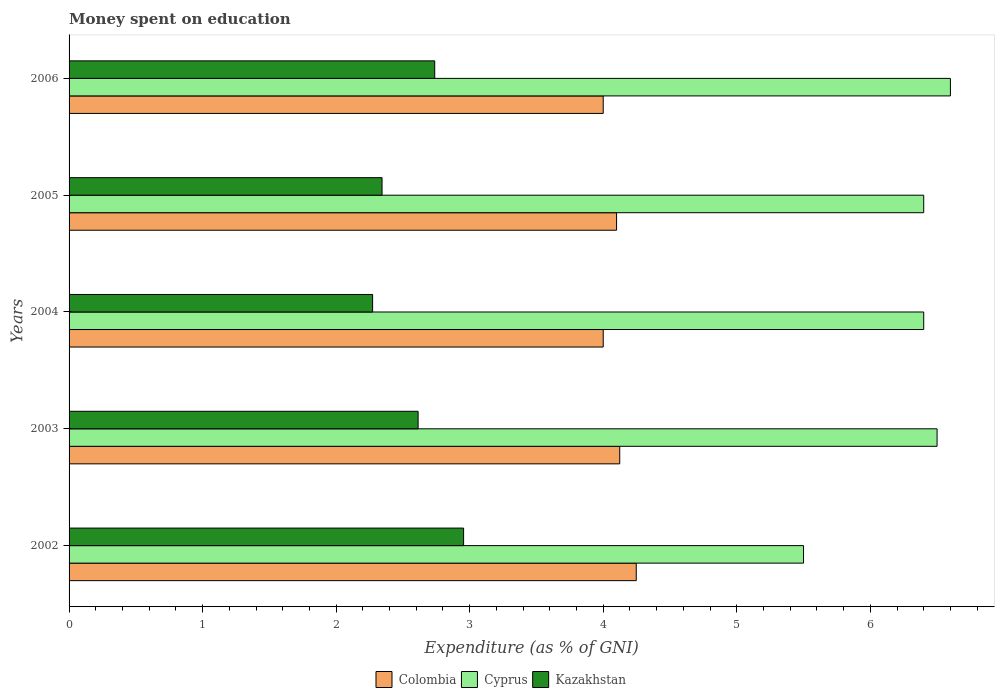How many different coloured bars are there?
Give a very brief answer. 3. How many groups of bars are there?
Make the answer very short. 5. Are the number of bars on each tick of the Y-axis equal?
Make the answer very short. Yes. How many bars are there on the 2nd tick from the top?
Offer a very short reply. 3. How many bars are there on the 1st tick from the bottom?
Ensure brevity in your answer.  3. What is the label of the 3rd group of bars from the top?
Your answer should be very brief. 2004. What is the amount of money spent on education in Colombia in 2002?
Ensure brevity in your answer.  4.25. Across all years, what is the maximum amount of money spent on education in Cyprus?
Provide a succinct answer. 6.6. Across all years, what is the minimum amount of money spent on education in Cyprus?
Give a very brief answer. 5.5. In which year was the amount of money spent on education in Kazakhstan maximum?
Your answer should be compact. 2002. What is the total amount of money spent on education in Cyprus in the graph?
Your answer should be compact. 31.4. What is the difference between the amount of money spent on education in Kazakhstan in 2002 and that in 2006?
Offer a terse response. 0.22. What is the difference between the amount of money spent on education in Cyprus in 2004 and the amount of money spent on education in Kazakhstan in 2003?
Keep it short and to the point. 3.79. What is the average amount of money spent on education in Colombia per year?
Your answer should be very brief. 4.09. In the year 2004, what is the difference between the amount of money spent on education in Kazakhstan and amount of money spent on education in Cyprus?
Give a very brief answer. -4.13. What is the ratio of the amount of money spent on education in Cyprus in 2002 to that in 2004?
Ensure brevity in your answer.  0.86. What is the difference between the highest and the second highest amount of money spent on education in Colombia?
Give a very brief answer. 0.12. What is the difference between the highest and the lowest amount of money spent on education in Cyprus?
Provide a short and direct response. 1.1. What does the 3rd bar from the top in 2005 represents?
Ensure brevity in your answer.  Colombia. What does the 3rd bar from the bottom in 2003 represents?
Provide a short and direct response. Kazakhstan. How many years are there in the graph?
Provide a succinct answer. 5. What is the difference between two consecutive major ticks on the X-axis?
Ensure brevity in your answer.  1. Are the values on the major ticks of X-axis written in scientific E-notation?
Ensure brevity in your answer.  No. Does the graph contain grids?
Your answer should be very brief. No. What is the title of the graph?
Keep it short and to the point. Money spent on education. What is the label or title of the X-axis?
Provide a succinct answer. Expenditure (as % of GNI). What is the label or title of the Y-axis?
Offer a very short reply. Years. What is the Expenditure (as % of GNI) of Colombia in 2002?
Make the answer very short. 4.25. What is the Expenditure (as % of GNI) in Kazakhstan in 2002?
Make the answer very short. 2.95. What is the Expenditure (as % of GNI) in Colombia in 2003?
Provide a succinct answer. 4.12. What is the Expenditure (as % of GNI) of Cyprus in 2003?
Make the answer very short. 6.5. What is the Expenditure (as % of GNI) in Kazakhstan in 2003?
Provide a succinct answer. 2.61. What is the Expenditure (as % of GNI) of Kazakhstan in 2004?
Offer a terse response. 2.27. What is the Expenditure (as % of GNI) in Colombia in 2005?
Give a very brief answer. 4.1. What is the Expenditure (as % of GNI) in Cyprus in 2005?
Your answer should be compact. 6.4. What is the Expenditure (as % of GNI) in Kazakhstan in 2005?
Your answer should be compact. 2.34. What is the Expenditure (as % of GNI) in Cyprus in 2006?
Your answer should be compact. 6.6. What is the Expenditure (as % of GNI) of Kazakhstan in 2006?
Your answer should be very brief. 2.74. Across all years, what is the maximum Expenditure (as % of GNI) in Colombia?
Your response must be concise. 4.25. Across all years, what is the maximum Expenditure (as % of GNI) in Cyprus?
Your response must be concise. 6.6. Across all years, what is the maximum Expenditure (as % of GNI) in Kazakhstan?
Your response must be concise. 2.95. Across all years, what is the minimum Expenditure (as % of GNI) in Cyprus?
Provide a succinct answer. 5.5. Across all years, what is the minimum Expenditure (as % of GNI) in Kazakhstan?
Make the answer very short. 2.27. What is the total Expenditure (as % of GNI) in Colombia in the graph?
Provide a succinct answer. 20.47. What is the total Expenditure (as % of GNI) of Cyprus in the graph?
Offer a terse response. 31.4. What is the total Expenditure (as % of GNI) of Kazakhstan in the graph?
Ensure brevity in your answer.  12.92. What is the difference between the Expenditure (as % of GNI) of Colombia in 2002 and that in 2003?
Ensure brevity in your answer.  0.12. What is the difference between the Expenditure (as % of GNI) in Kazakhstan in 2002 and that in 2003?
Offer a very short reply. 0.34. What is the difference between the Expenditure (as % of GNI) in Colombia in 2002 and that in 2004?
Offer a terse response. 0.25. What is the difference between the Expenditure (as % of GNI) of Kazakhstan in 2002 and that in 2004?
Provide a succinct answer. 0.68. What is the difference between the Expenditure (as % of GNI) of Colombia in 2002 and that in 2005?
Offer a very short reply. 0.15. What is the difference between the Expenditure (as % of GNI) of Kazakhstan in 2002 and that in 2005?
Give a very brief answer. 0.61. What is the difference between the Expenditure (as % of GNI) in Colombia in 2002 and that in 2006?
Provide a short and direct response. 0.25. What is the difference between the Expenditure (as % of GNI) in Cyprus in 2002 and that in 2006?
Offer a very short reply. -1.1. What is the difference between the Expenditure (as % of GNI) in Kazakhstan in 2002 and that in 2006?
Ensure brevity in your answer.  0.22. What is the difference between the Expenditure (as % of GNI) in Colombia in 2003 and that in 2004?
Your answer should be compact. 0.12. What is the difference between the Expenditure (as % of GNI) of Cyprus in 2003 and that in 2004?
Provide a succinct answer. 0.1. What is the difference between the Expenditure (as % of GNI) in Kazakhstan in 2003 and that in 2004?
Offer a terse response. 0.34. What is the difference between the Expenditure (as % of GNI) in Colombia in 2003 and that in 2005?
Keep it short and to the point. 0.02. What is the difference between the Expenditure (as % of GNI) of Kazakhstan in 2003 and that in 2005?
Your response must be concise. 0.27. What is the difference between the Expenditure (as % of GNI) of Colombia in 2003 and that in 2006?
Provide a short and direct response. 0.12. What is the difference between the Expenditure (as % of GNI) of Kazakhstan in 2003 and that in 2006?
Offer a very short reply. -0.12. What is the difference between the Expenditure (as % of GNI) of Cyprus in 2004 and that in 2005?
Give a very brief answer. 0. What is the difference between the Expenditure (as % of GNI) in Kazakhstan in 2004 and that in 2005?
Offer a very short reply. -0.07. What is the difference between the Expenditure (as % of GNI) of Colombia in 2004 and that in 2006?
Provide a succinct answer. 0. What is the difference between the Expenditure (as % of GNI) of Cyprus in 2004 and that in 2006?
Make the answer very short. -0.2. What is the difference between the Expenditure (as % of GNI) in Kazakhstan in 2004 and that in 2006?
Provide a succinct answer. -0.47. What is the difference between the Expenditure (as % of GNI) of Colombia in 2005 and that in 2006?
Keep it short and to the point. 0.1. What is the difference between the Expenditure (as % of GNI) in Kazakhstan in 2005 and that in 2006?
Keep it short and to the point. -0.39. What is the difference between the Expenditure (as % of GNI) in Colombia in 2002 and the Expenditure (as % of GNI) in Cyprus in 2003?
Make the answer very short. -2.25. What is the difference between the Expenditure (as % of GNI) in Colombia in 2002 and the Expenditure (as % of GNI) in Kazakhstan in 2003?
Keep it short and to the point. 1.63. What is the difference between the Expenditure (as % of GNI) in Cyprus in 2002 and the Expenditure (as % of GNI) in Kazakhstan in 2003?
Keep it short and to the point. 2.89. What is the difference between the Expenditure (as % of GNI) in Colombia in 2002 and the Expenditure (as % of GNI) in Cyprus in 2004?
Your response must be concise. -2.15. What is the difference between the Expenditure (as % of GNI) in Colombia in 2002 and the Expenditure (as % of GNI) in Kazakhstan in 2004?
Offer a terse response. 1.97. What is the difference between the Expenditure (as % of GNI) in Cyprus in 2002 and the Expenditure (as % of GNI) in Kazakhstan in 2004?
Give a very brief answer. 3.23. What is the difference between the Expenditure (as % of GNI) in Colombia in 2002 and the Expenditure (as % of GNI) in Cyprus in 2005?
Your answer should be very brief. -2.15. What is the difference between the Expenditure (as % of GNI) of Colombia in 2002 and the Expenditure (as % of GNI) of Kazakhstan in 2005?
Keep it short and to the point. 1.9. What is the difference between the Expenditure (as % of GNI) of Cyprus in 2002 and the Expenditure (as % of GNI) of Kazakhstan in 2005?
Your response must be concise. 3.16. What is the difference between the Expenditure (as % of GNI) in Colombia in 2002 and the Expenditure (as % of GNI) in Cyprus in 2006?
Ensure brevity in your answer.  -2.35. What is the difference between the Expenditure (as % of GNI) of Colombia in 2002 and the Expenditure (as % of GNI) of Kazakhstan in 2006?
Keep it short and to the point. 1.51. What is the difference between the Expenditure (as % of GNI) of Cyprus in 2002 and the Expenditure (as % of GNI) of Kazakhstan in 2006?
Make the answer very short. 2.76. What is the difference between the Expenditure (as % of GNI) of Colombia in 2003 and the Expenditure (as % of GNI) of Cyprus in 2004?
Provide a short and direct response. -2.28. What is the difference between the Expenditure (as % of GNI) of Colombia in 2003 and the Expenditure (as % of GNI) of Kazakhstan in 2004?
Keep it short and to the point. 1.85. What is the difference between the Expenditure (as % of GNI) of Cyprus in 2003 and the Expenditure (as % of GNI) of Kazakhstan in 2004?
Your answer should be very brief. 4.23. What is the difference between the Expenditure (as % of GNI) in Colombia in 2003 and the Expenditure (as % of GNI) in Cyprus in 2005?
Give a very brief answer. -2.28. What is the difference between the Expenditure (as % of GNI) of Colombia in 2003 and the Expenditure (as % of GNI) of Kazakhstan in 2005?
Provide a succinct answer. 1.78. What is the difference between the Expenditure (as % of GNI) of Cyprus in 2003 and the Expenditure (as % of GNI) of Kazakhstan in 2005?
Provide a short and direct response. 4.16. What is the difference between the Expenditure (as % of GNI) of Colombia in 2003 and the Expenditure (as % of GNI) of Cyprus in 2006?
Offer a terse response. -2.48. What is the difference between the Expenditure (as % of GNI) of Colombia in 2003 and the Expenditure (as % of GNI) of Kazakhstan in 2006?
Your response must be concise. 1.39. What is the difference between the Expenditure (as % of GNI) of Cyprus in 2003 and the Expenditure (as % of GNI) of Kazakhstan in 2006?
Ensure brevity in your answer.  3.76. What is the difference between the Expenditure (as % of GNI) in Colombia in 2004 and the Expenditure (as % of GNI) in Cyprus in 2005?
Ensure brevity in your answer.  -2.4. What is the difference between the Expenditure (as % of GNI) of Colombia in 2004 and the Expenditure (as % of GNI) of Kazakhstan in 2005?
Offer a very short reply. 1.66. What is the difference between the Expenditure (as % of GNI) of Cyprus in 2004 and the Expenditure (as % of GNI) of Kazakhstan in 2005?
Offer a very short reply. 4.06. What is the difference between the Expenditure (as % of GNI) of Colombia in 2004 and the Expenditure (as % of GNI) of Kazakhstan in 2006?
Your answer should be compact. 1.26. What is the difference between the Expenditure (as % of GNI) of Cyprus in 2004 and the Expenditure (as % of GNI) of Kazakhstan in 2006?
Offer a very short reply. 3.66. What is the difference between the Expenditure (as % of GNI) in Colombia in 2005 and the Expenditure (as % of GNI) in Cyprus in 2006?
Provide a short and direct response. -2.5. What is the difference between the Expenditure (as % of GNI) of Colombia in 2005 and the Expenditure (as % of GNI) of Kazakhstan in 2006?
Your answer should be very brief. 1.36. What is the difference between the Expenditure (as % of GNI) in Cyprus in 2005 and the Expenditure (as % of GNI) in Kazakhstan in 2006?
Keep it short and to the point. 3.66. What is the average Expenditure (as % of GNI) of Colombia per year?
Make the answer very short. 4.09. What is the average Expenditure (as % of GNI) in Cyprus per year?
Provide a succinct answer. 6.28. What is the average Expenditure (as % of GNI) in Kazakhstan per year?
Ensure brevity in your answer.  2.58. In the year 2002, what is the difference between the Expenditure (as % of GNI) of Colombia and Expenditure (as % of GNI) of Cyprus?
Ensure brevity in your answer.  -1.25. In the year 2002, what is the difference between the Expenditure (as % of GNI) in Colombia and Expenditure (as % of GNI) in Kazakhstan?
Keep it short and to the point. 1.29. In the year 2002, what is the difference between the Expenditure (as % of GNI) in Cyprus and Expenditure (as % of GNI) in Kazakhstan?
Your response must be concise. 2.55. In the year 2003, what is the difference between the Expenditure (as % of GNI) of Colombia and Expenditure (as % of GNI) of Cyprus?
Provide a succinct answer. -2.38. In the year 2003, what is the difference between the Expenditure (as % of GNI) in Colombia and Expenditure (as % of GNI) in Kazakhstan?
Provide a short and direct response. 1.51. In the year 2003, what is the difference between the Expenditure (as % of GNI) in Cyprus and Expenditure (as % of GNI) in Kazakhstan?
Your response must be concise. 3.89. In the year 2004, what is the difference between the Expenditure (as % of GNI) of Colombia and Expenditure (as % of GNI) of Kazakhstan?
Provide a short and direct response. 1.73. In the year 2004, what is the difference between the Expenditure (as % of GNI) in Cyprus and Expenditure (as % of GNI) in Kazakhstan?
Offer a terse response. 4.13. In the year 2005, what is the difference between the Expenditure (as % of GNI) in Colombia and Expenditure (as % of GNI) in Kazakhstan?
Provide a short and direct response. 1.76. In the year 2005, what is the difference between the Expenditure (as % of GNI) in Cyprus and Expenditure (as % of GNI) in Kazakhstan?
Your answer should be compact. 4.06. In the year 2006, what is the difference between the Expenditure (as % of GNI) of Colombia and Expenditure (as % of GNI) of Cyprus?
Keep it short and to the point. -2.6. In the year 2006, what is the difference between the Expenditure (as % of GNI) of Colombia and Expenditure (as % of GNI) of Kazakhstan?
Give a very brief answer. 1.26. In the year 2006, what is the difference between the Expenditure (as % of GNI) of Cyprus and Expenditure (as % of GNI) of Kazakhstan?
Give a very brief answer. 3.86. What is the ratio of the Expenditure (as % of GNI) of Colombia in 2002 to that in 2003?
Your response must be concise. 1.03. What is the ratio of the Expenditure (as % of GNI) in Cyprus in 2002 to that in 2003?
Give a very brief answer. 0.85. What is the ratio of the Expenditure (as % of GNI) of Kazakhstan in 2002 to that in 2003?
Your answer should be very brief. 1.13. What is the ratio of the Expenditure (as % of GNI) of Colombia in 2002 to that in 2004?
Your answer should be compact. 1.06. What is the ratio of the Expenditure (as % of GNI) in Cyprus in 2002 to that in 2004?
Give a very brief answer. 0.86. What is the ratio of the Expenditure (as % of GNI) in Kazakhstan in 2002 to that in 2004?
Your answer should be very brief. 1.3. What is the ratio of the Expenditure (as % of GNI) in Colombia in 2002 to that in 2005?
Ensure brevity in your answer.  1.04. What is the ratio of the Expenditure (as % of GNI) of Cyprus in 2002 to that in 2005?
Give a very brief answer. 0.86. What is the ratio of the Expenditure (as % of GNI) of Kazakhstan in 2002 to that in 2005?
Ensure brevity in your answer.  1.26. What is the ratio of the Expenditure (as % of GNI) of Colombia in 2002 to that in 2006?
Make the answer very short. 1.06. What is the ratio of the Expenditure (as % of GNI) of Kazakhstan in 2002 to that in 2006?
Your answer should be very brief. 1.08. What is the ratio of the Expenditure (as % of GNI) of Colombia in 2003 to that in 2004?
Give a very brief answer. 1.03. What is the ratio of the Expenditure (as % of GNI) of Cyprus in 2003 to that in 2004?
Give a very brief answer. 1.02. What is the ratio of the Expenditure (as % of GNI) in Kazakhstan in 2003 to that in 2004?
Offer a terse response. 1.15. What is the ratio of the Expenditure (as % of GNI) in Colombia in 2003 to that in 2005?
Offer a terse response. 1.01. What is the ratio of the Expenditure (as % of GNI) in Cyprus in 2003 to that in 2005?
Offer a very short reply. 1.02. What is the ratio of the Expenditure (as % of GNI) of Kazakhstan in 2003 to that in 2005?
Your answer should be very brief. 1.12. What is the ratio of the Expenditure (as % of GNI) in Colombia in 2003 to that in 2006?
Provide a short and direct response. 1.03. What is the ratio of the Expenditure (as % of GNI) of Cyprus in 2003 to that in 2006?
Make the answer very short. 0.98. What is the ratio of the Expenditure (as % of GNI) in Kazakhstan in 2003 to that in 2006?
Your response must be concise. 0.95. What is the ratio of the Expenditure (as % of GNI) in Colombia in 2004 to that in 2005?
Your answer should be compact. 0.98. What is the ratio of the Expenditure (as % of GNI) of Kazakhstan in 2004 to that in 2005?
Your answer should be compact. 0.97. What is the ratio of the Expenditure (as % of GNI) in Colombia in 2004 to that in 2006?
Keep it short and to the point. 1. What is the ratio of the Expenditure (as % of GNI) of Cyprus in 2004 to that in 2006?
Your answer should be compact. 0.97. What is the ratio of the Expenditure (as % of GNI) of Kazakhstan in 2004 to that in 2006?
Provide a short and direct response. 0.83. What is the ratio of the Expenditure (as % of GNI) of Cyprus in 2005 to that in 2006?
Provide a succinct answer. 0.97. What is the ratio of the Expenditure (as % of GNI) in Kazakhstan in 2005 to that in 2006?
Your answer should be compact. 0.86. What is the difference between the highest and the second highest Expenditure (as % of GNI) in Colombia?
Your answer should be compact. 0.12. What is the difference between the highest and the second highest Expenditure (as % of GNI) of Cyprus?
Keep it short and to the point. 0.1. What is the difference between the highest and the second highest Expenditure (as % of GNI) in Kazakhstan?
Make the answer very short. 0.22. What is the difference between the highest and the lowest Expenditure (as % of GNI) of Colombia?
Keep it short and to the point. 0.25. What is the difference between the highest and the lowest Expenditure (as % of GNI) of Cyprus?
Your answer should be very brief. 1.1. What is the difference between the highest and the lowest Expenditure (as % of GNI) in Kazakhstan?
Ensure brevity in your answer.  0.68. 